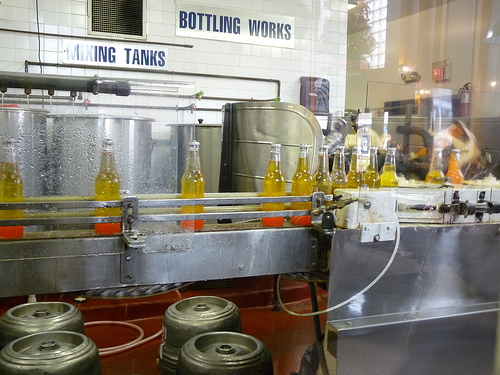<image>
Can you confirm if the bottle is next to the tank? Yes. The bottle is positioned adjacent to the tank, located nearby in the same general area. 